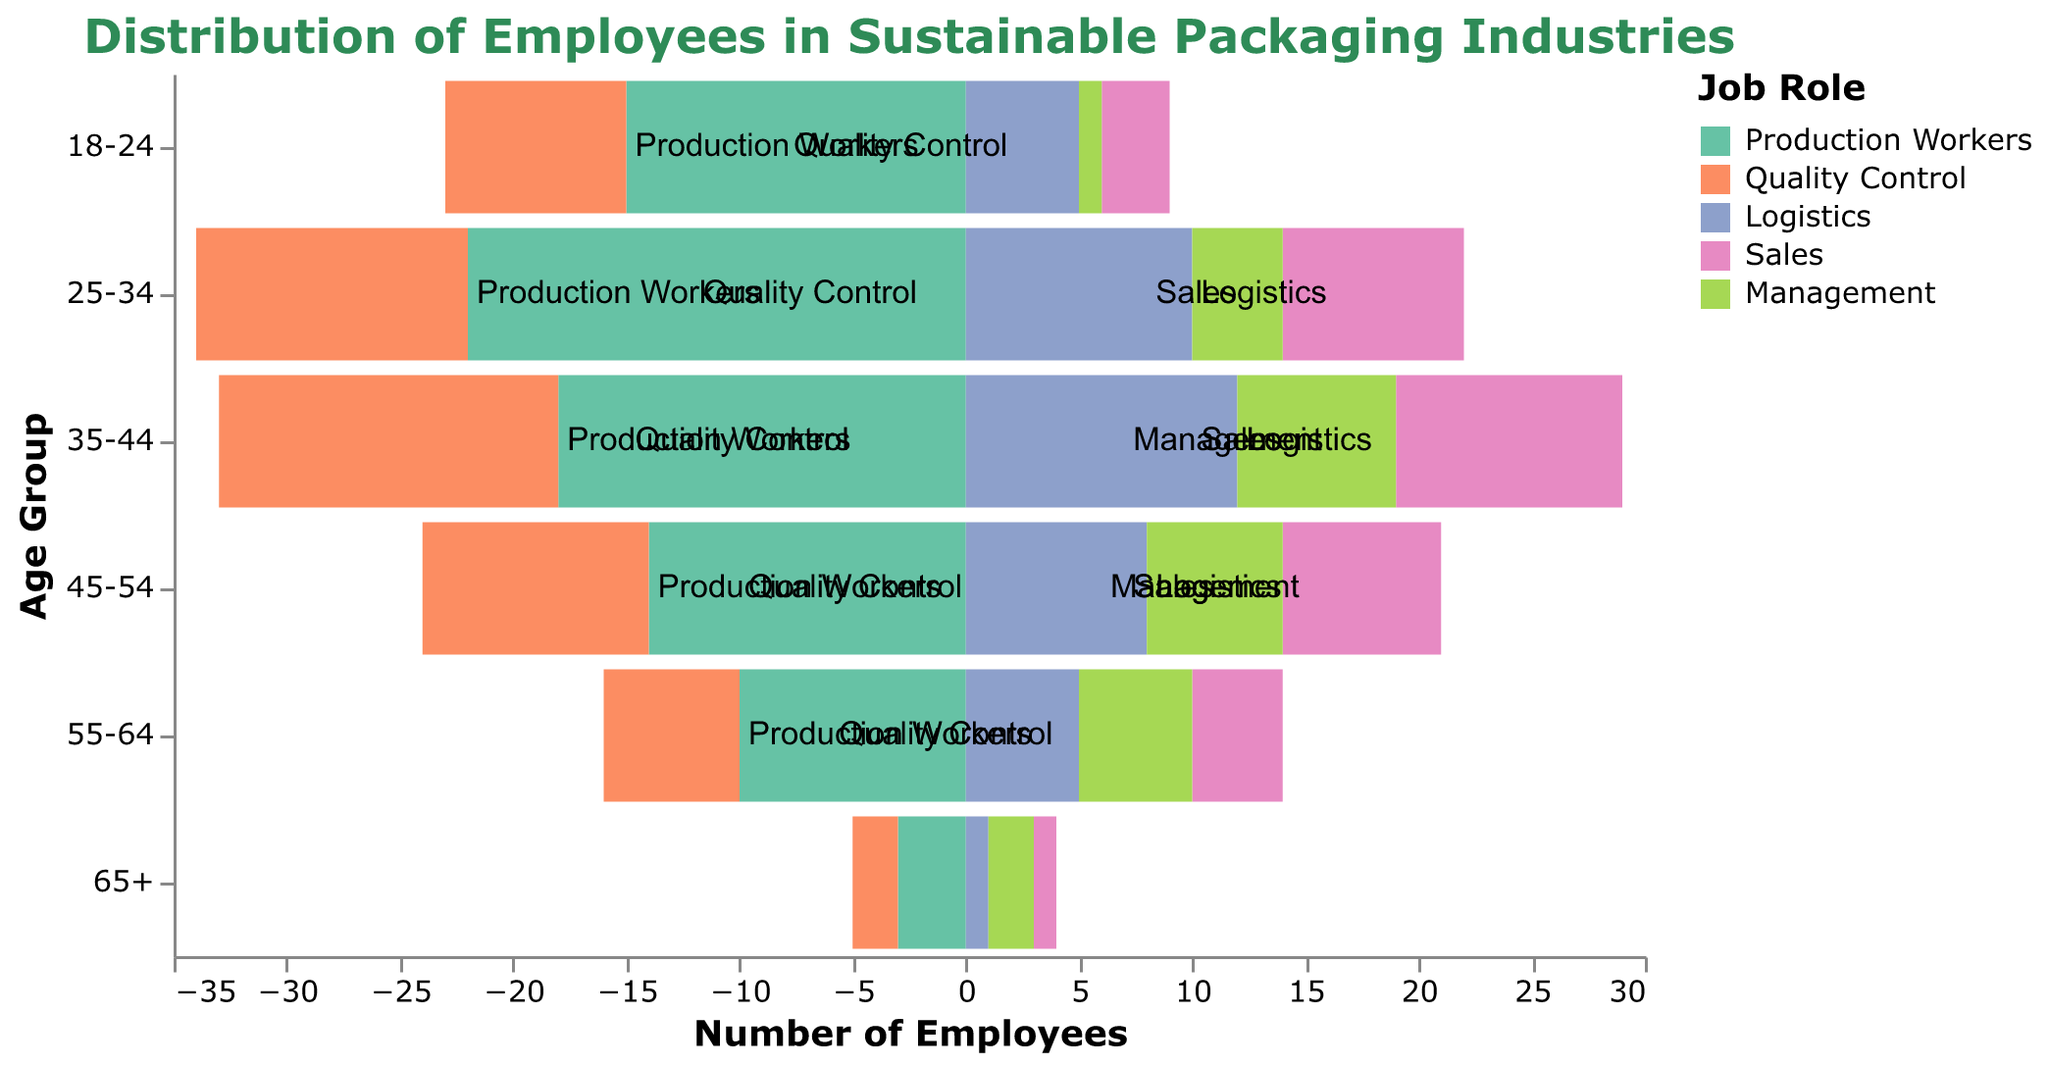What is the title of the figure? The title is often found at the top and gives a brief description of what the figure represents. In this case, it clearly states the focus of the figure.
Answer: Distribution of Employees in Sustainable Packaging Industries Which age group has the highest number of production workers? Look at the section for Production Workers across all age groups and identify the one with the longest bar.
Answer: 25-34 How many management employees are there in the 45-54 age group? Locate the Management category in the 45-54 age group and read the corresponding value.
Answer: 6 Compare the number of sales employees in the 18-24 and 35-44 age groups. Which group has more? Compare the length of the bars for Sales in the 18-24 and 35-44 age groups. The group with the longer bar has more employees.
Answer: 35-44 What is the total number of employees in the 25-34 age group? Sum the values for all job roles in the 25-34 age group: Production Workers (22), Quality Control (12), Logistics (10), Sales (8), and Management (4). The total is 22 + 12 + 10 + 8 + 4.
Answer: 56 Which job role has the highest number of employees in the 18-24 age group? Look at the values for each job role in the 18-24 age group and find the largest one.
Answer: Production Workers What is the percentage of management employees in the 35-44 age group relative to the total number of employees in that age group? Calculate the total number of employees in the 35-44 age group: Production Workers (18), Quality Control (15), Logistics (12), Sales (10), and Management (7). The total is 18 + 15 + 12 + 10 + 7 = 62. Divide the number of Management employees (7) by the total number (62) and multiply by 100 to get the percentage.
Answer: 11.29% How does the number of quality control employees in the 55-64 age group compare to those in the 18-24 age group? Compare the values of Quality Control employees in the 55-64 and 18-24 age groups. In the 55-64 age group, there are 6, and in the 18-24 age group, there are 8.
Answer: Less in 55-64 What is the trend in the number of logistics employees as age increases? Observe the bars for Logistics across the age groups to discern any trend. The values are 5, 10, 12, 8, 5, and 1 from youngest to oldest.
Answer: Increases then decreases At what age group does the number of Production Workers start to decline significantly? Identify the point at which there is a marked decrease in the length of the bars for Production Workers. The numbers are 15, 22, 18, 14, 10, and 3. The significant decline starts after 25-34.
Answer: 35-44 